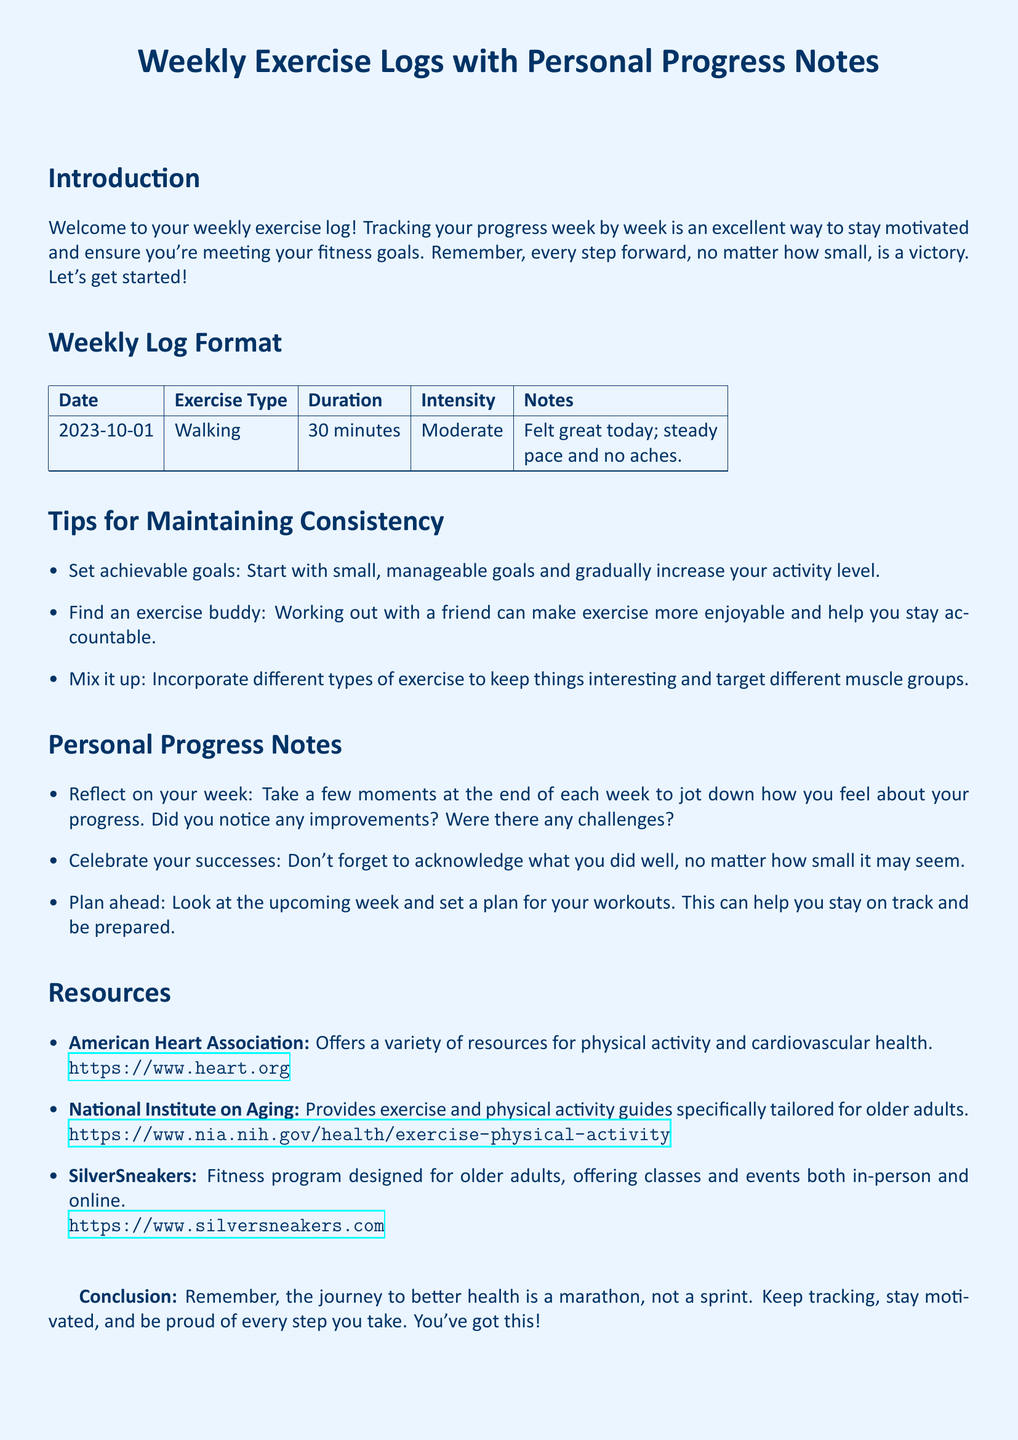What is the exercise type logged for 2023-10-01? The exercise type is listed in the weekly log under the corresponding date.
Answer: Walking What was the duration of the exercise on 2023-10-01? The duration is specified in the weekly log for the date mentioned.
Answer: 30 minutes What intensity level was recorded for the exercise? The intensity level is detailed in the weekly log alongside the date and exercise type.
Answer: Moderate What is one tip for maintaining consistency mentioned in the document? Tips for consistency are listed in the section dedicated to that topic.
Answer: Set achievable goals Which organization offers resources for cardiovascular health? The resources section names organizations that provide support and information related to exercise.
Answer: American Heart Association How should one reflect on their week according to personal progress notes? The personal progress section provides guidance on how to track and reflect on one's activities.
Answer: Take a few moments to jot down how you feel about your progress What is highlighted as an important aspect of the health journey? The conclusion summarizes the essence of the exercise log in one sentence.
Answer: A marathon, not a sprint 